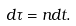Convert formula to latex. <formula><loc_0><loc_0><loc_500><loc_500>d \tau = n d t .</formula> 